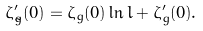<formula> <loc_0><loc_0><loc_500><loc_500>\zeta _ { \tilde { g } } ^ { \prime } ( 0 ) = \zeta _ { g } ( 0 ) \ln l + \zeta _ { g } ^ { \prime } ( 0 ) .</formula> 